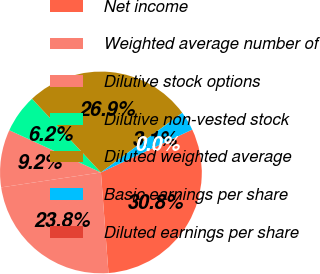Convert chart. <chart><loc_0><loc_0><loc_500><loc_500><pie_chart><fcel>Net income<fcel>Weighted average number of<fcel>Dilutive stock options<fcel>Dilutive non-vested stock<fcel>Diluted weighted average<fcel>Basic earnings per share<fcel>Diluted earnings per share<nl><fcel>30.79%<fcel>23.83%<fcel>9.24%<fcel>6.16%<fcel>26.9%<fcel>3.08%<fcel>0.0%<nl></chart> 